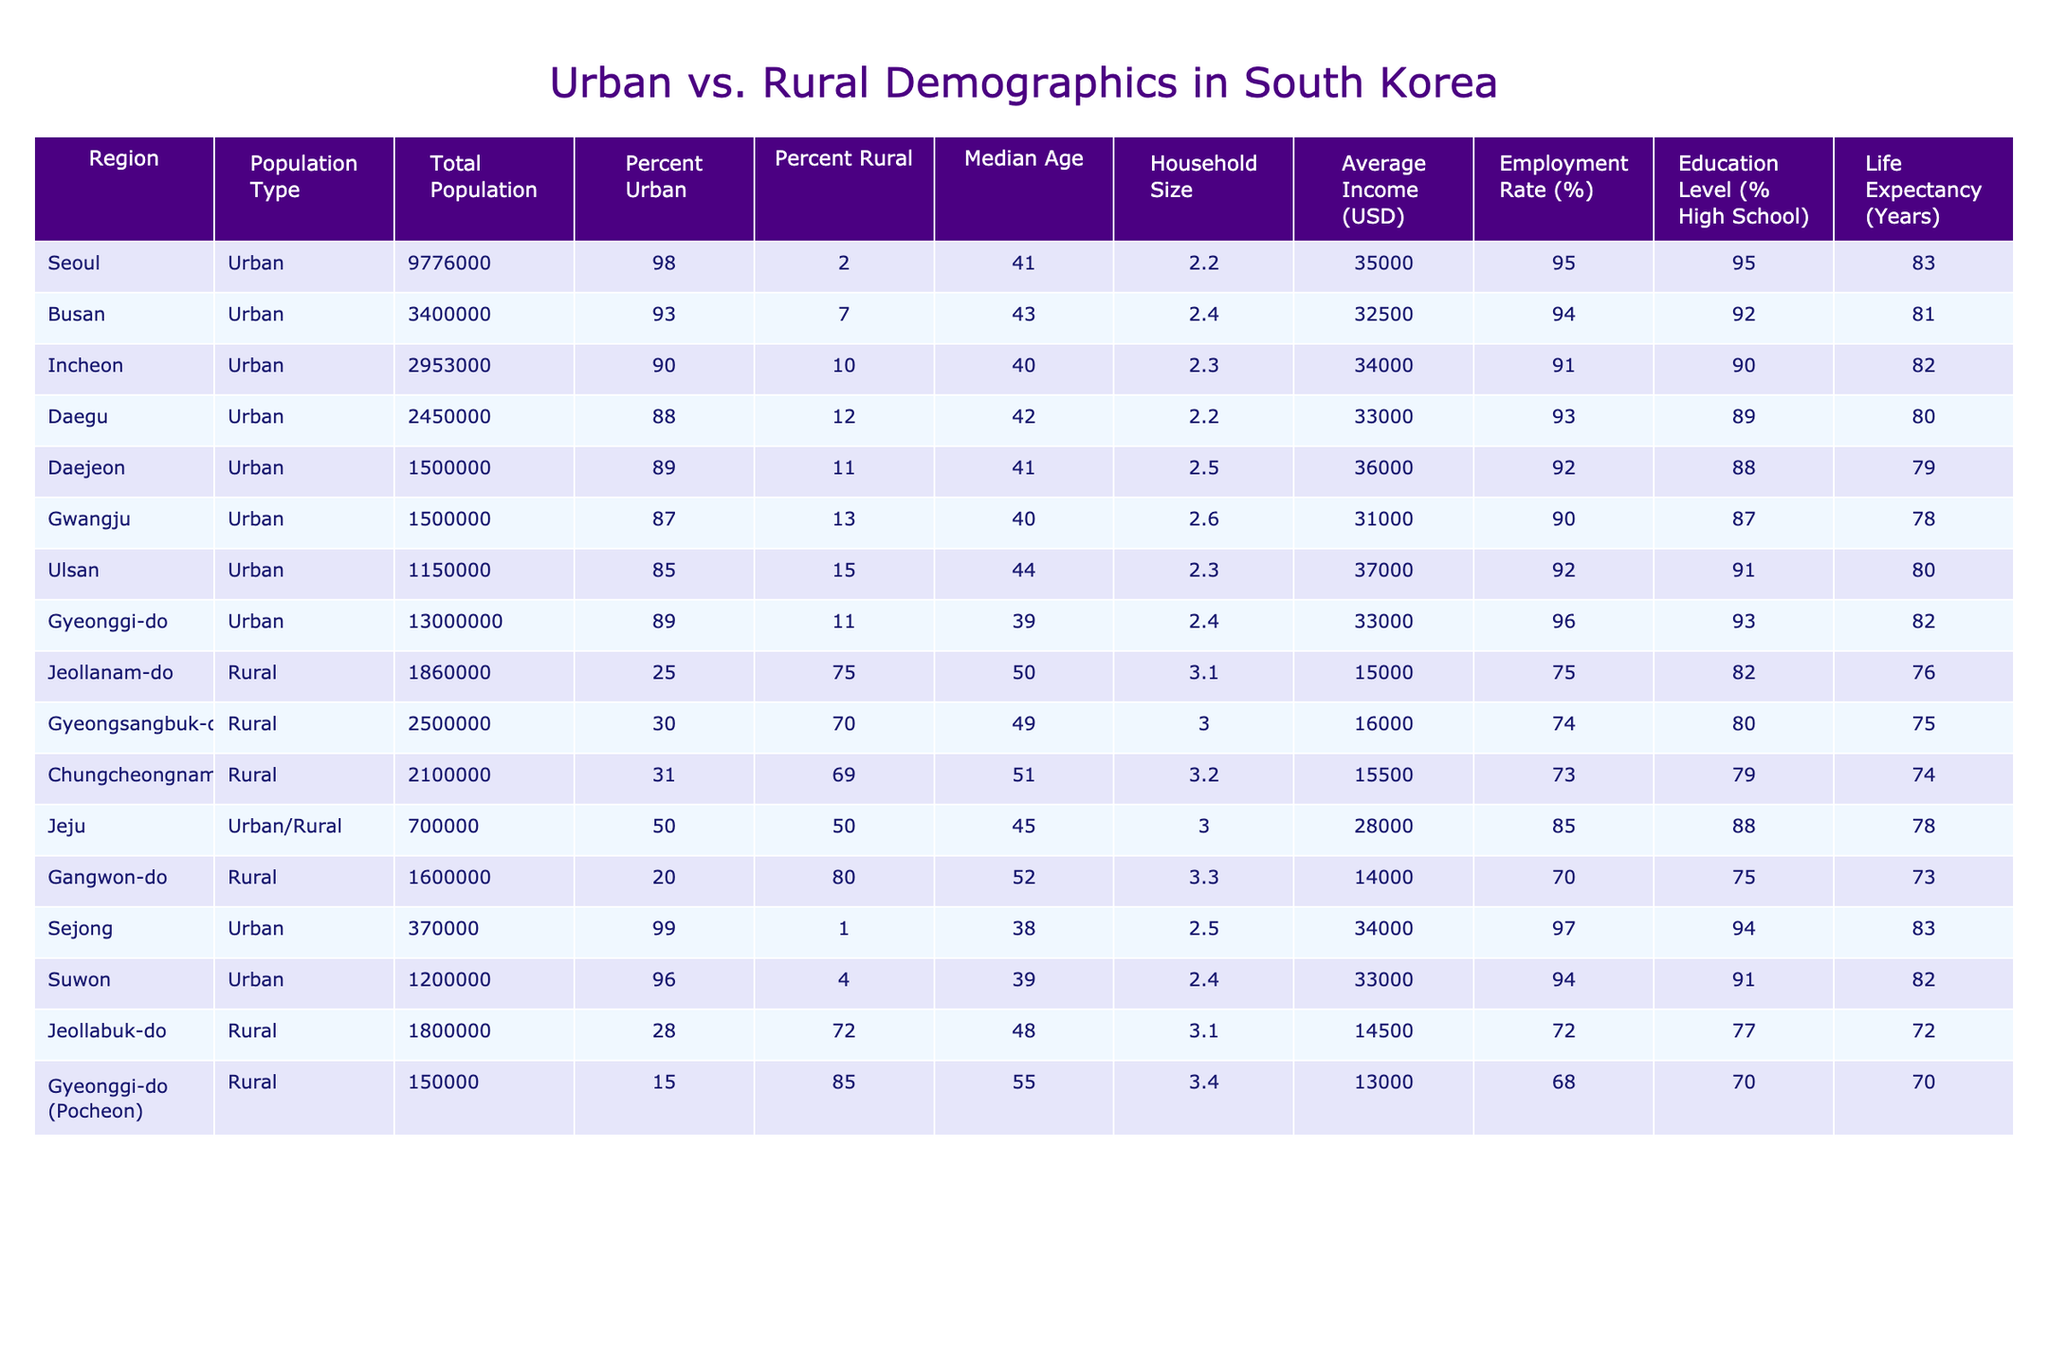What is the total population of Seoul? The table lists Seoul’s total population under "Total Population" as 9,776,000.
Answer: 9,776,000 Which region has the highest average income? The average incomes are found in the "Average Income (USD)" column. Seoul has the highest at $35,000.
Answer: Seoul What percentage of the population in Jeollanam-do is rural? In the "Percent Rural" column for Jeollanam-do, it shows 72%.
Answer: 72% What is the median age for the rural population in Gangwon-do? The "Median Age" for Gangwon-do in the table is listed as 52 years.
Answer: 52 What is the average household size for urban areas compared to rural areas? The average household sizes listed are 2.4 for urban and 3.1 for rural. To find the average for urban, sum the values (2.2 + 2.4 + 2.3 + 2.2 + 2.5 + 2.6 + 2.3 + 2.4 + 2.5 + 2.4) = 24.1, divided by 10 results in 2.41. For rural, (3.1 + 3.0 + 3.2 + 3.0 + 3.3 + 3.1 + 3.0 + 3.4) = 24.5, divided by 8 results in 3.06. Hence, urban average = 2.41 and rural average = 3.06.
Answer: Urban: 2.41, Rural: 3.06 Is the employment rate higher in urban or rural areas? Comparing the "Employment Rate" column, the lowest rate for urban areas is 85%, and the highest for rural areas is 75%. Since urban areas mostly have higher percentages, we can conclude urban areas have a higher employment rate overall.
Answer: Urban areas By how much does the population of Ulsan exceed that of Jeju? Ulsan's population is 1,150,000 and Jeju's is 700,000; therefore, the difference is 1,150,000 - 700,000 = 450,000.
Answer: 450,000 What is the life expectancy for the rural region with the lowest average income? In the table, Gyeonggi-do (Pocheon) has the lowest average income at $13,000 with a life expectancy of 70 years.
Answer: 70 Is the percentage of urban population in Daejeon greater than that in Gwangju? Daejeon has 89% urban and Gwangju has 87%. Since 89% is greater than 87%, this statement is true.
Answer: Yes What is the total rural population when combining the three rural regions listed? The total rural populations are Jeollanam-do (1,860,000), Gyeongsangbuk-do (2,500,000), and Chungcheongnam-do (2,100,000). Adding these together gives 1,860,000 + 2,500,000 + 2,100,000 = 6,460,000.
Answer: 6,460,000 What is the percentage of high school education in Sejong? The table shows that 94% of the population in Sejong has a high school education.
Answer: 94% 